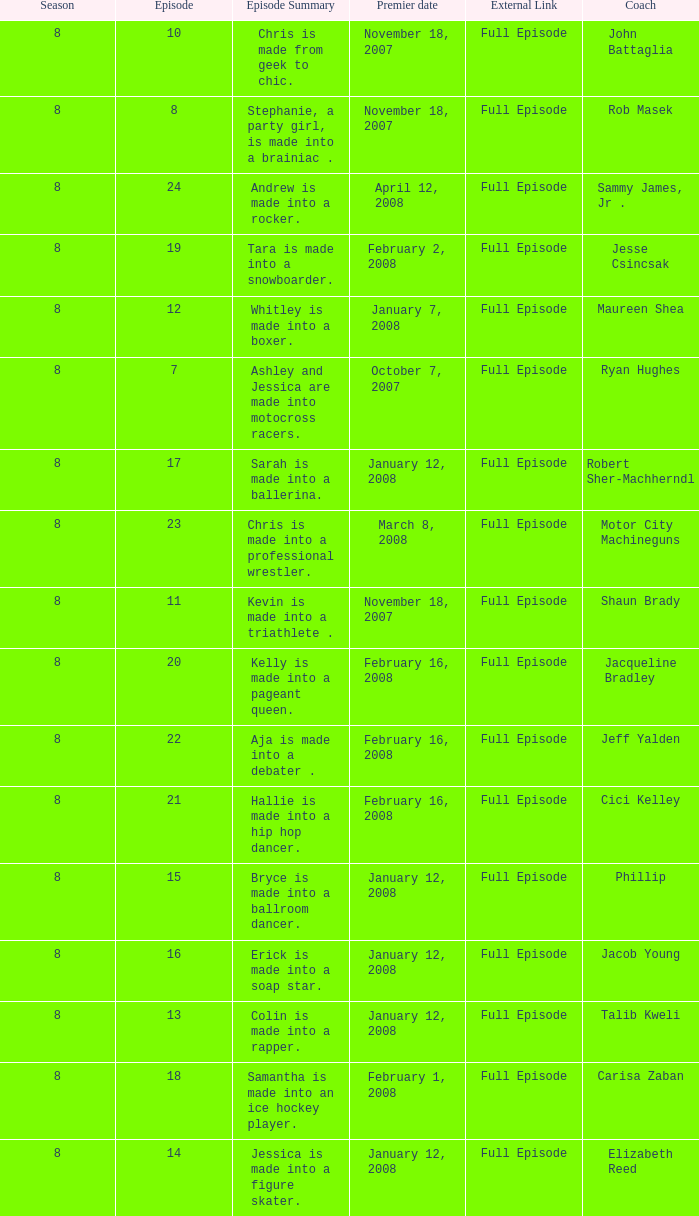What coach premiered February 16, 2008 later than episode 21.0? Jeff Yalden. 